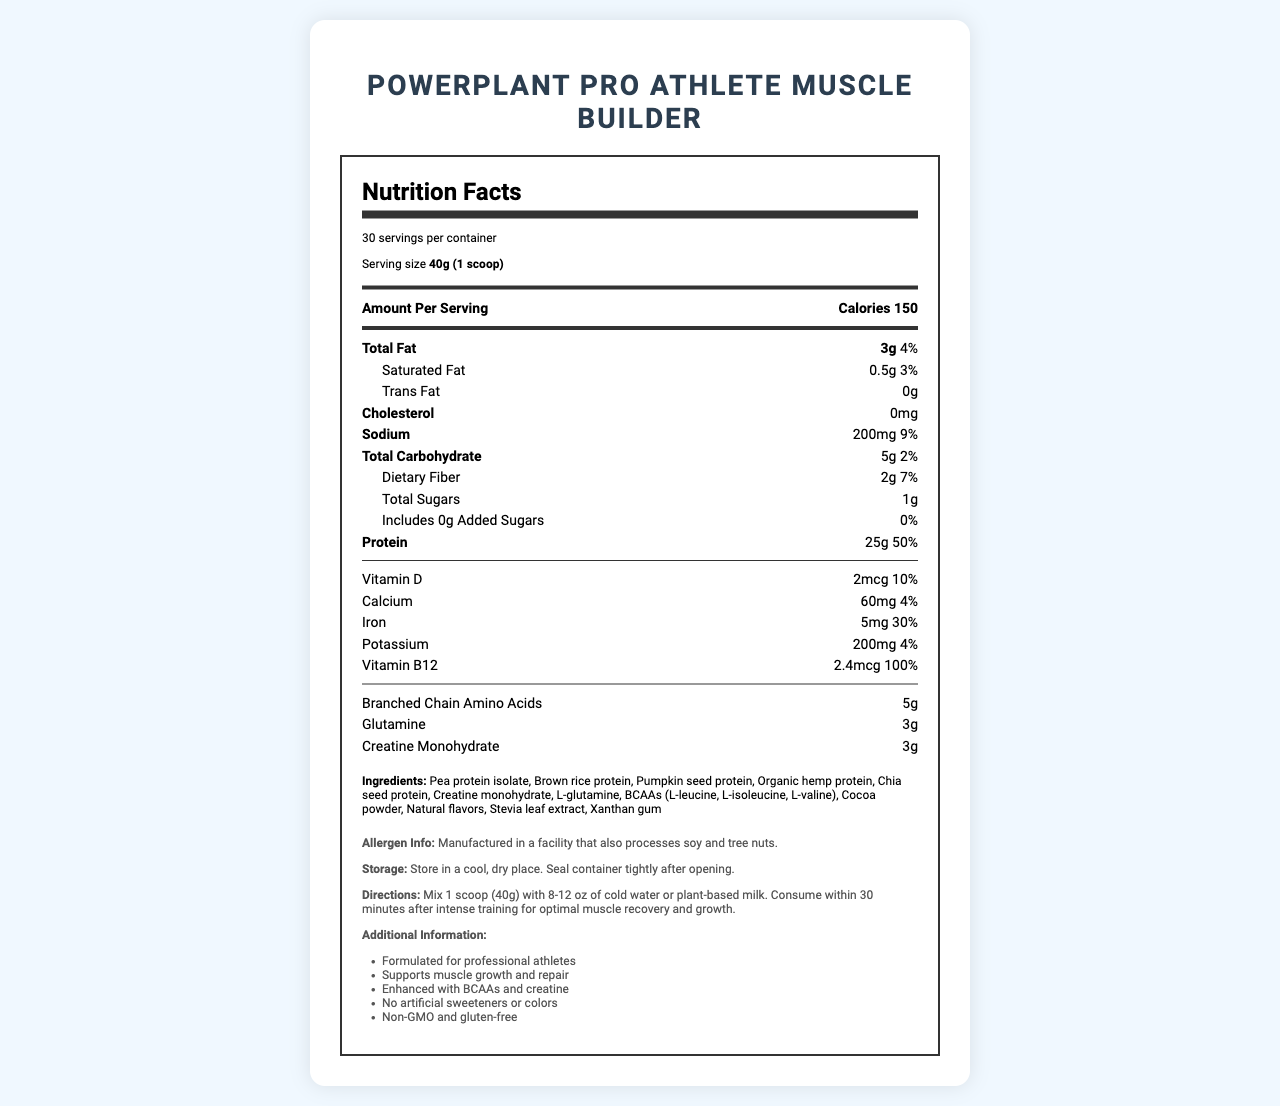what is the serving size? The serving size is mentioned in the section titled "Serving size" and it is listed as 40g (1 scoop).
Answer: 40g (1 scoop) how many servings are in the container? The number of servings per container is specified under "servings per container" and is 30.
Answer: 30 what are the calories per serving? The number of calories per serving is listed as "Calories 150" right at the start of the "Amount Per Serving" section.
Answer: 150 how much protein is in one serving? The protein amount per serving is listed as "Protein 25g" under the nutrient section of the nutrition facts.
Answer: 25g what is the daily value percentage of protein? The daily value percentage of protein is given as "50%" next to the protein amount.
Answer: 50% what are the main protein sources in the ingredients? These sources are listed in the ingredients section: "Pea protein isolate, Brown rice protein, Pumpkin seed protein, Organic hemp protein, Chia seed protein".
Answer: Pea protein isolate, Brown rice protein, Pumpkin seed protein, Organic hemp protein, Chia seed protein how much vitamin b12 is in one serving? The Vitamin B12 amount per serving is listed as "Vitamin B12 2.4mcg".
Answer: 2.4mcg what is the daily value percentage of iron? The daily value percentage of iron is provided as "30%" in the nutrient section.
Answer: 30% does this product contain any artificial sweeteners? In the additional information section, it is stated that the product has "No artificial sweeteners or colors".
Answer: No how much sodium is in one serving? The sodium content per serving is mentioned as "200mg" under the nutrient section.
Answer: 200mg how much added sugars does this product contain? The added sugars amount per serving is listed as "0g" under the nutrient section.
Answer: 0g how much dietary fiber is in one serving? The dietary fiber amount per serving is listed as "Dietary Fiber 2g" under the nutrient section.
Answer: 2g what other supplements are included in the product? These supplements are listed under the nutrient section: "Branched Chain Amino Acids 5g", "Glutamine 3g", and "Creatine Monohydrate 3g".
Answer: BCAAs, Glutamine, Creatine Monohydrate how many grams of branched chain amino acids are included? The amount of Branched Chain Amino Acids is mentioned as "5g".
Answer: 5g how many grams of glutamine are included? The amount of glutamine per serving is specified as "3g".
Answer: 3g what type of sweetener is used? A. Aspartame B. Sucralose C. Stevia The ingredients list mentions "Stevia leaf extract" as the sweetener used.
Answer: C which vitamin has a daily value percentage of 100%? A. Vitamin D B. Calcium C. Vitamin B12 Vitamin B12 has a daily value percentage of 100%.
Answer: C how much potassium is in one serving? A. 60mg B. 5mg C. 200mg D. 2mcg The potassium content per serving is listed as "200mg".
Answer: C does this product contain gluten? In the additional information section, it is noted that the product is "gluten-free".
Answer: No does this product contain cholesterol? The cholesterol content is mentioned as "0mg" under the nutrient section.
Answer: No explain the storage instructions for this product. The storage instructions are clearly given under the storage section: "Store in a cool, dry place. Seal container tightly after opening."
Answer: Store in a cool, dry place. Seal container tightly after opening. describe the overall purpose and key features of the product. The product is tailored for professional athletes aiming to boost muscle growth and repair. Key features include high protein content, additional sports supplements like BCAAs and creatine, and the absence of artificial sweeteners and gluten.
Answer: The product, PowerPlant Pro Athlete Muscle Builder, is a plant-based protein powder designed for muscle growth and repair. It includes BCAAs, glutamine, and creatine to enhance performance. It provides 25g of protein per serving and is free from artificial sweeteners and gluten. what is the price of the product? The document does not mention the price of the product.
Answer: Not enough information 